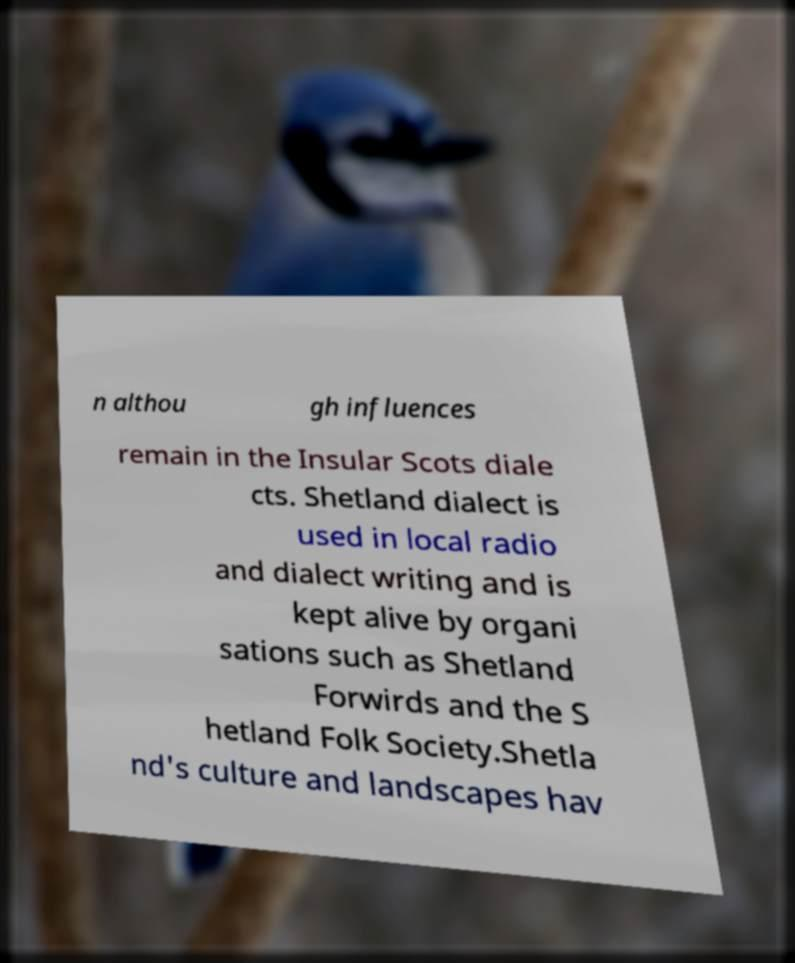I need the written content from this picture converted into text. Can you do that? n althou gh influences remain in the Insular Scots diale cts. Shetland dialect is used in local radio and dialect writing and is kept alive by organi sations such as Shetland Forwirds and the S hetland Folk Society.Shetla nd's culture and landscapes hav 